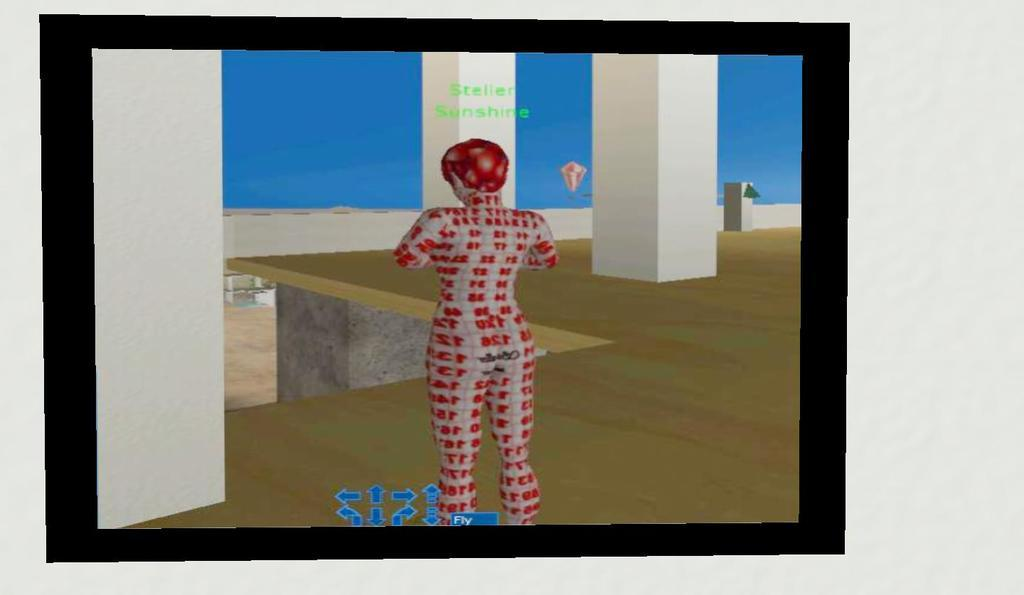What architectural features can be seen in the image? There are pillars in the image. Can you describe the person in the image? There is a person standing on the floor in the image. What scientific discovery is being made by the person in the image? There is no indication of a scientific discovery being made in the image; it only shows a person standing on the floor. Is there a ship visible in the image? No, there is no ship present in the image. 